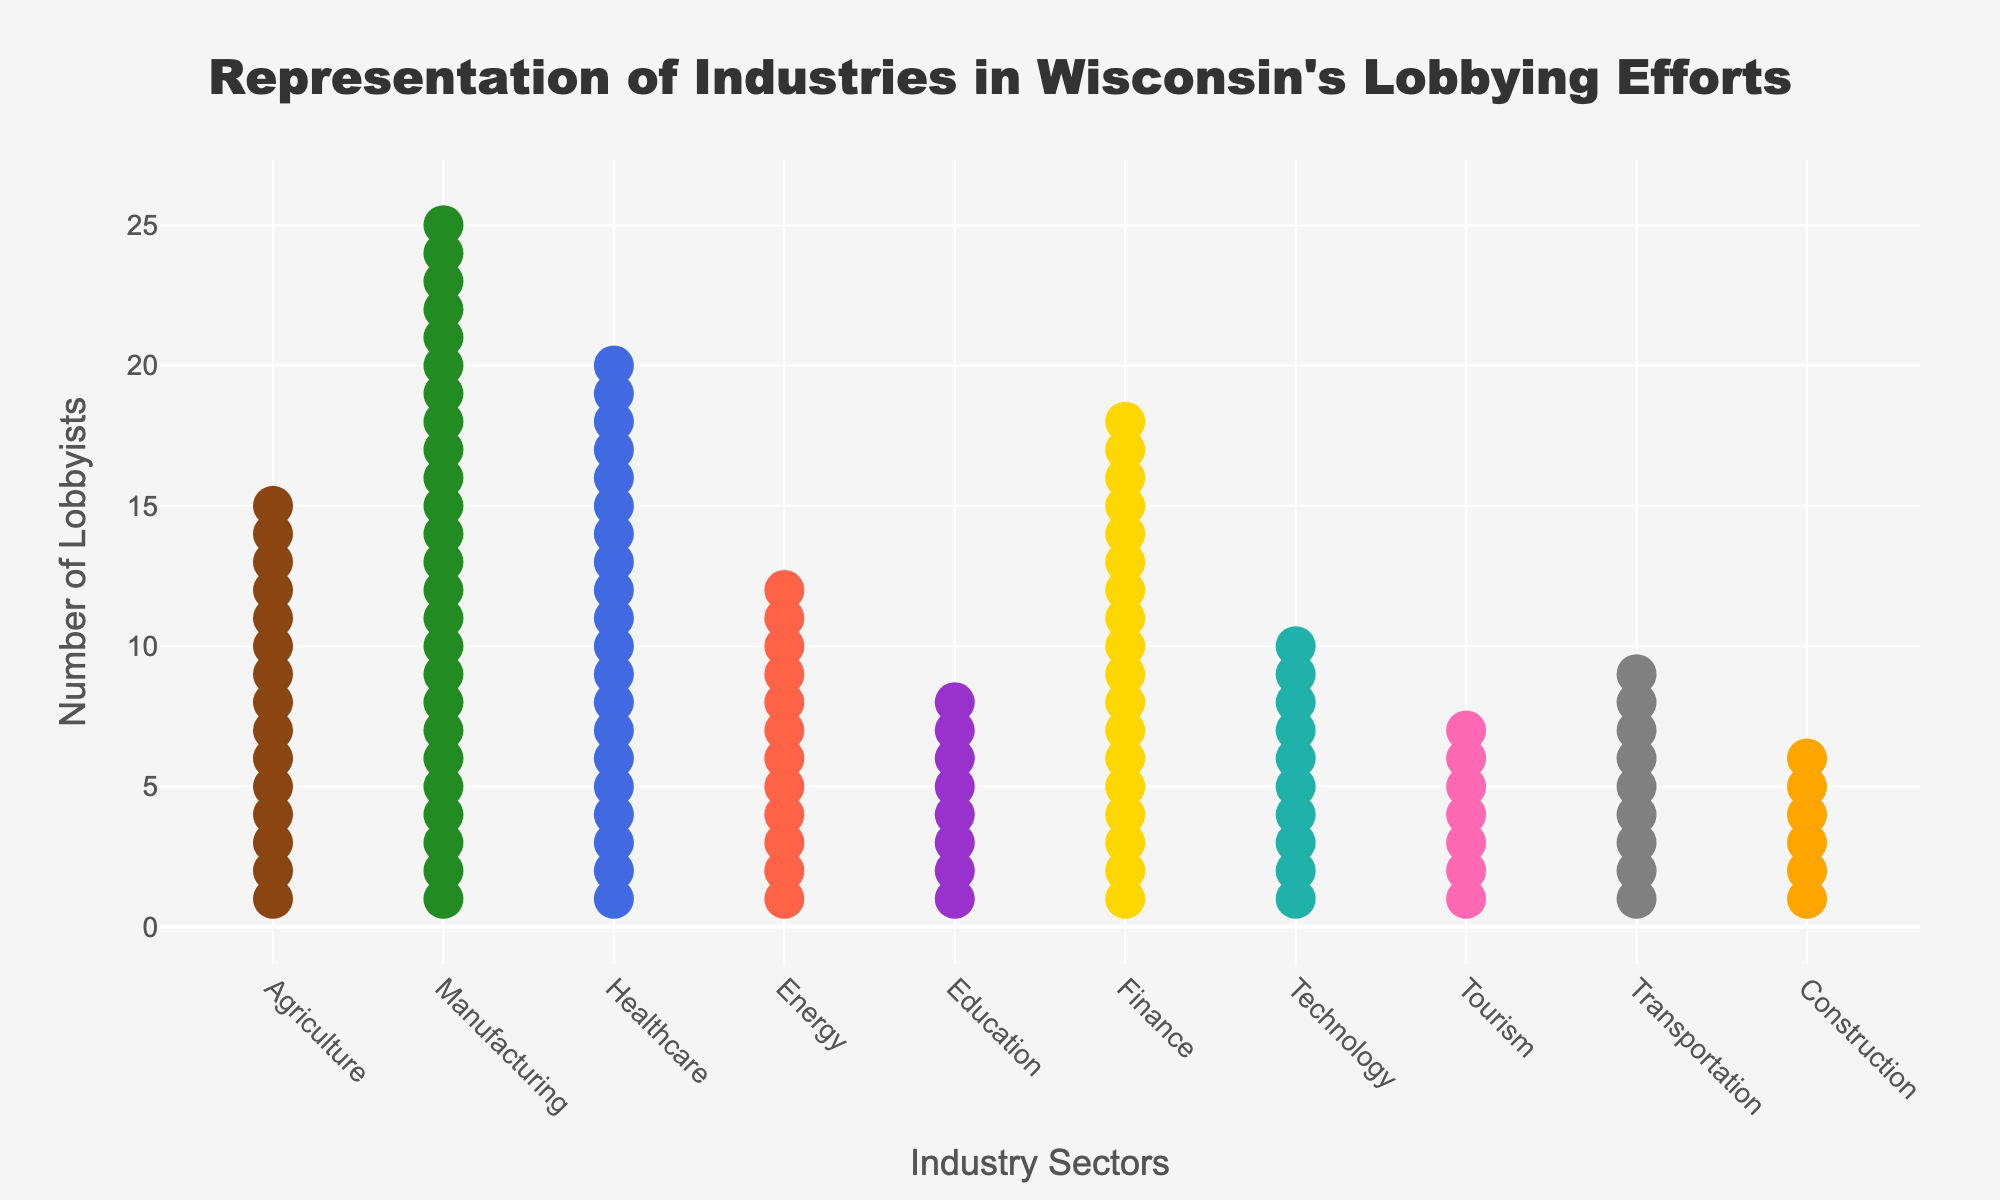What is the title of the plot? The title of the plot is positioned at the top center and clearly states the purpose of the figure, helping to set the context for the viewer.
Answer: Representation of Industries in Wisconsin's Lobbying Efforts Which industry has the highest number of lobbyists? By visually inspecting the height and number of symbols stacked for each industry, we can identify the industry with the most symbols.
Answer: Manufacturing What does the y-axis represent in this plot? The y-axis label is a straightforward indication of what the vertical axis measures in the plot.
Answer: Number of Lobbyists How many lobbyists are representing the Technology industry? By counting the symbols or referring to the hover text for the Technology sector, we can find the exact number of lobbyists.
Answer: 10 Which industries have fewer than 10 lobbyists? By identifying the industries with fewer symbols than the marker height for 10, we can list the industries with under 10 lobbyists.
Answer: Education, Tourism, Transportation, Construction What is the combined number of lobbyists in the Finance and Healthcare industries? Summing the number of lobbyists for both the Finance (18) and Healthcare (20) industries gives the total.
Answer: 38 Which industry is represented by 12 lobbyists and what color is it symbolized by? By matching the number of symbols and their color in the plot, we can identify the industry and its color.
Answer: Energy, red Is the number of lobbyists in the Agriculture industry more than in the Technology industry? We compare the stack height or the hover text values for Agriculture (15) and Technology (10).
Answer: Yes How many industries are represented by fewer than 15 lobbyists? By counting the number of industries with stacks shorter than the marker height for 15, we get the total.
Answer: 6 What is the difference in the number of lobbyists between the Transportation and Manufacturing industries? Subtracting the number of lobbyists in Transportation (9) from those in Manufacturing (25) provides the difference.
Answer: 16 